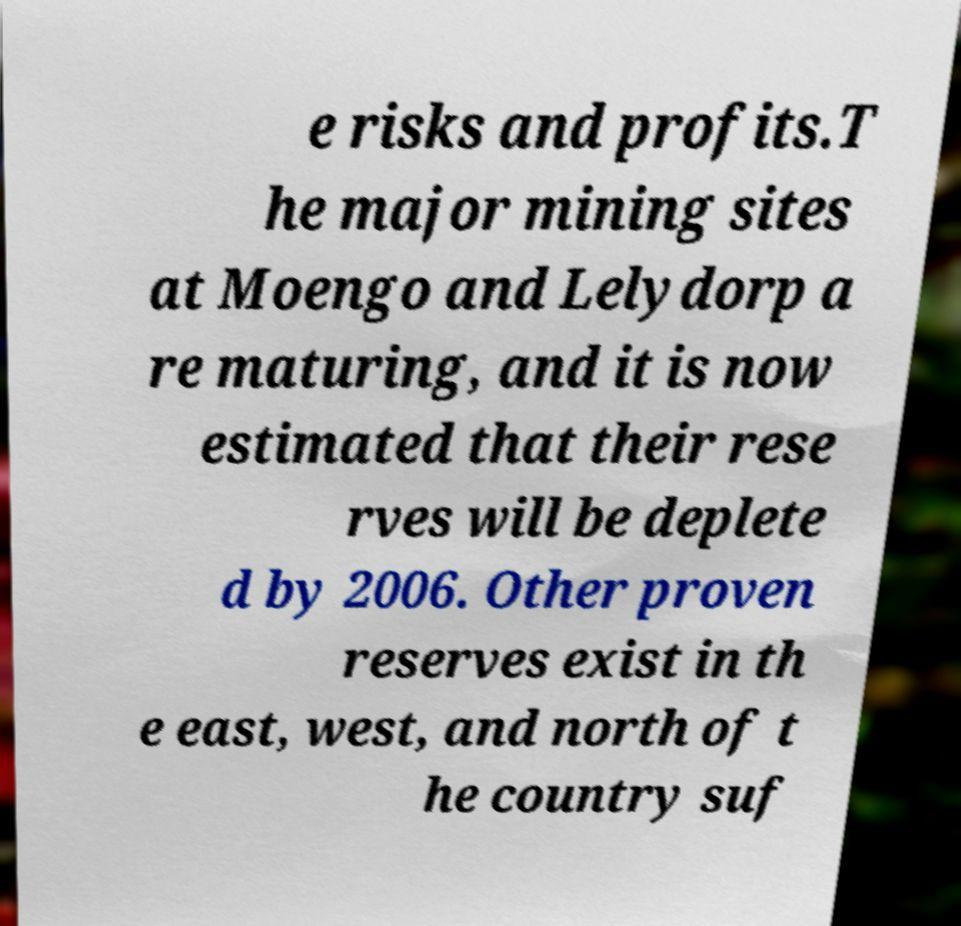Please read and relay the text visible in this image. What does it say? e risks and profits.T he major mining sites at Moengo and Lelydorp a re maturing, and it is now estimated that their rese rves will be deplete d by 2006. Other proven reserves exist in th e east, west, and north of t he country suf 